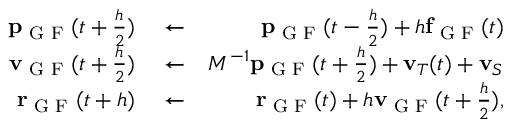Convert formula to latex. <formula><loc_0><loc_0><loc_500><loc_500>\begin{array} { r l r } { { p } _ { G F } ( t + \frac { h } { 2 } ) } & \leftarrow } & { { p } _ { G F } ( t - \frac { h } { 2 } ) + h { f } _ { G F } ( t ) } \\ { { v } _ { G F } ( t + \frac { h } { 2 } ) } & \leftarrow } & { M ^ { - 1 } { p } _ { G F } ( t + \frac { h } { 2 } ) + { v } _ { T } ( t ) + { v } _ { S } } \\ { { r } _ { G F } ( t + h ) } & \leftarrow } & { { r } _ { G F } ( t ) + h { v } _ { G F } ( t + \frac { h } { 2 } ) , } \end{array}</formula> 